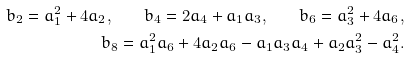Convert formula to latex. <formula><loc_0><loc_0><loc_500><loc_500>b _ { 2 } = a _ { 1 } ^ { 2 } + 4 a _ { 2 } , \quad b _ { 4 } = 2 a _ { 4 } + a _ { 1 } a _ { 3 } , \quad b _ { 6 } = a _ { 3 } ^ { 2 } + 4 a _ { 6 } , \\ b _ { 8 } = a _ { 1 } ^ { 2 } a _ { 6 } + 4 a _ { 2 } a _ { 6 } - a _ { 1 } a _ { 3 } a _ { 4 } + a _ { 2 } a _ { 3 } ^ { 2 } - a _ { 4 } ^ { 2 } .</formula> 